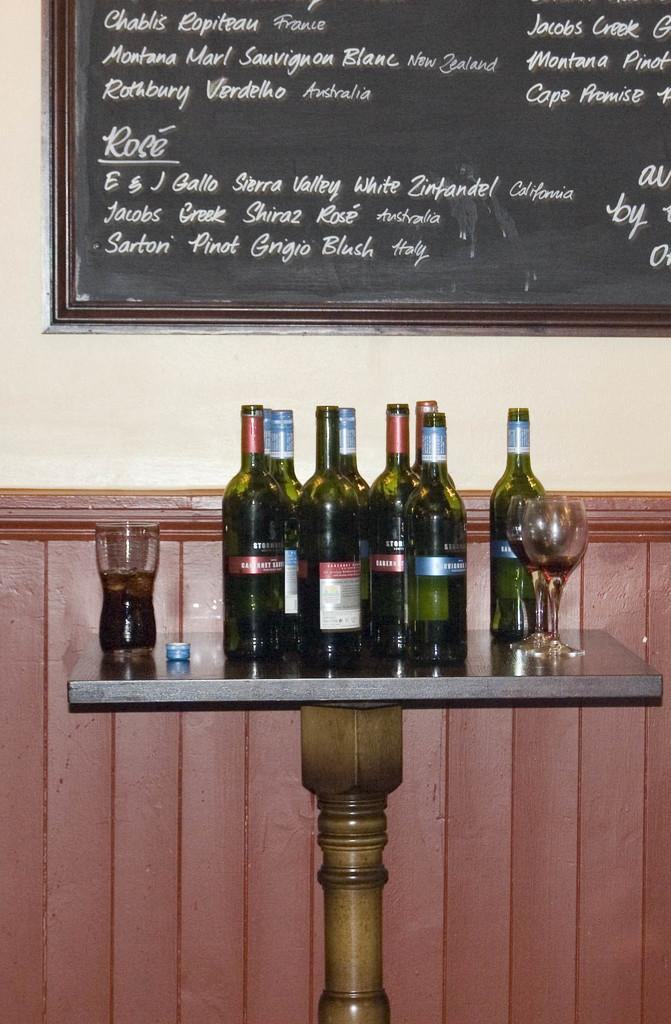What type of beverage containers are visible in the image? There are wine bottles in the image. What can be found on the table in the image? There are glasses on the table in the image. What is attached to the wall in the image? There is a board attached to the wall in the image. What type of game is being played on the board in the image? There is no game being played on the board in the image; it is just a board attached to the wall. How is the board being used for transport in the image? The board is not being used for transport in the image; it is simply attached to the wall. 